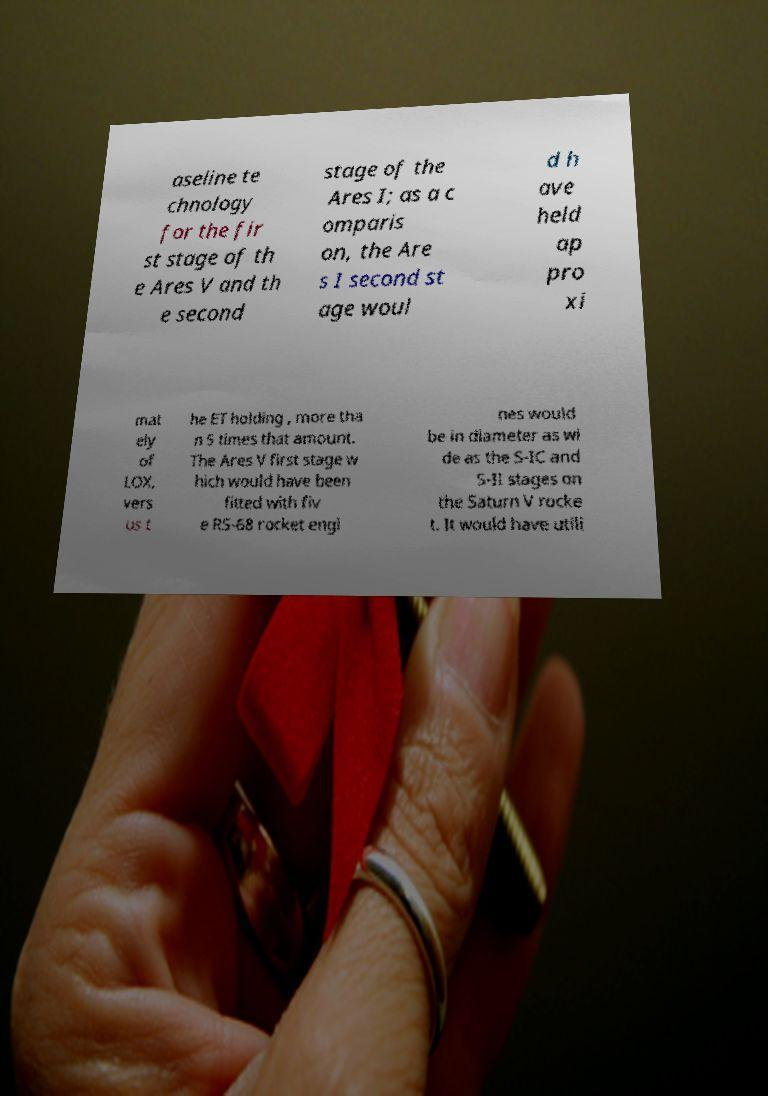Can you accurately transcribe the text from the provided image for me? aseline te chnology for the fir st stage of th e Ares V and th e second stage of the Ares I; as a c omparis on, the Are s I second st age woul d h ave held ap pro xi mat ely of LOX, vers us t he ET holding , more tha n 5 times that amount. The Ares V first stage w hich would have been fitted with fiv e RS-68 rocket engi nes would be in diameter as wi de as the S-IC and S-II stages on the Saturn V rocke t. It would have utili 